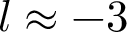<formula> <loc_0><loc_0><loc_500><loc_500>l \approx - 3</formula> 